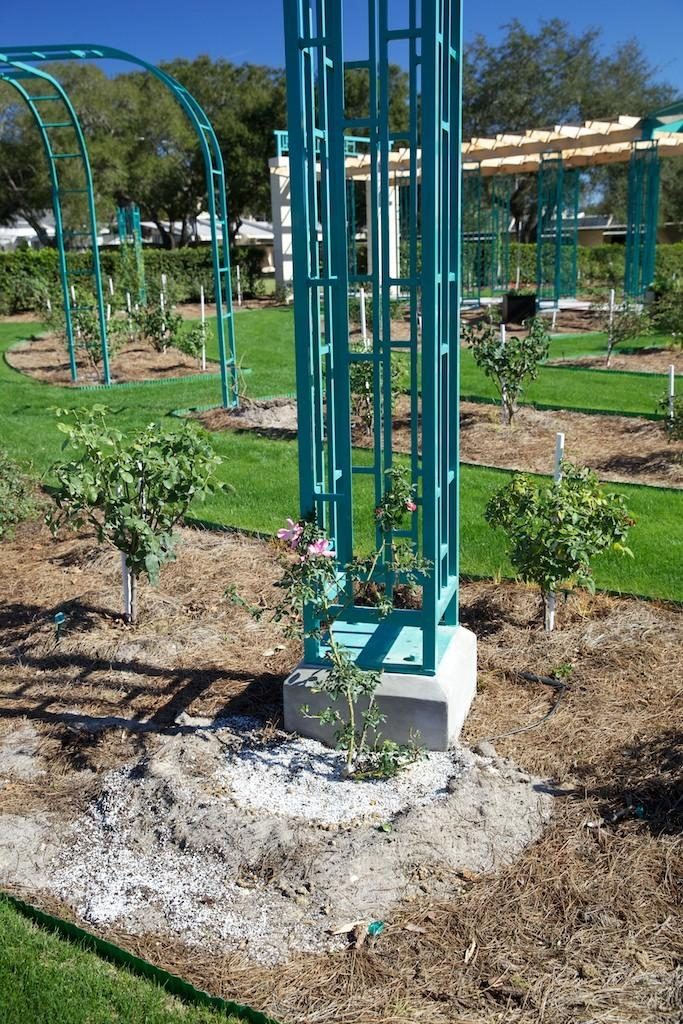What type of objects can be seen in the image? There are metal objects in the image. What is visible beneath the objects? The ground is visible in the image. What type of vegetation is present in the image? There is grass, plants, and trees in the image. What color are the white-colored objects in the image? The white-colored objects in the image are white. What part of the natural environment is visible in the image? The sky is visible in the image. How many plantation workers can be seen in the image? There is no reference to a plantation or any workers in the image, so it is not possible to answer that question. 